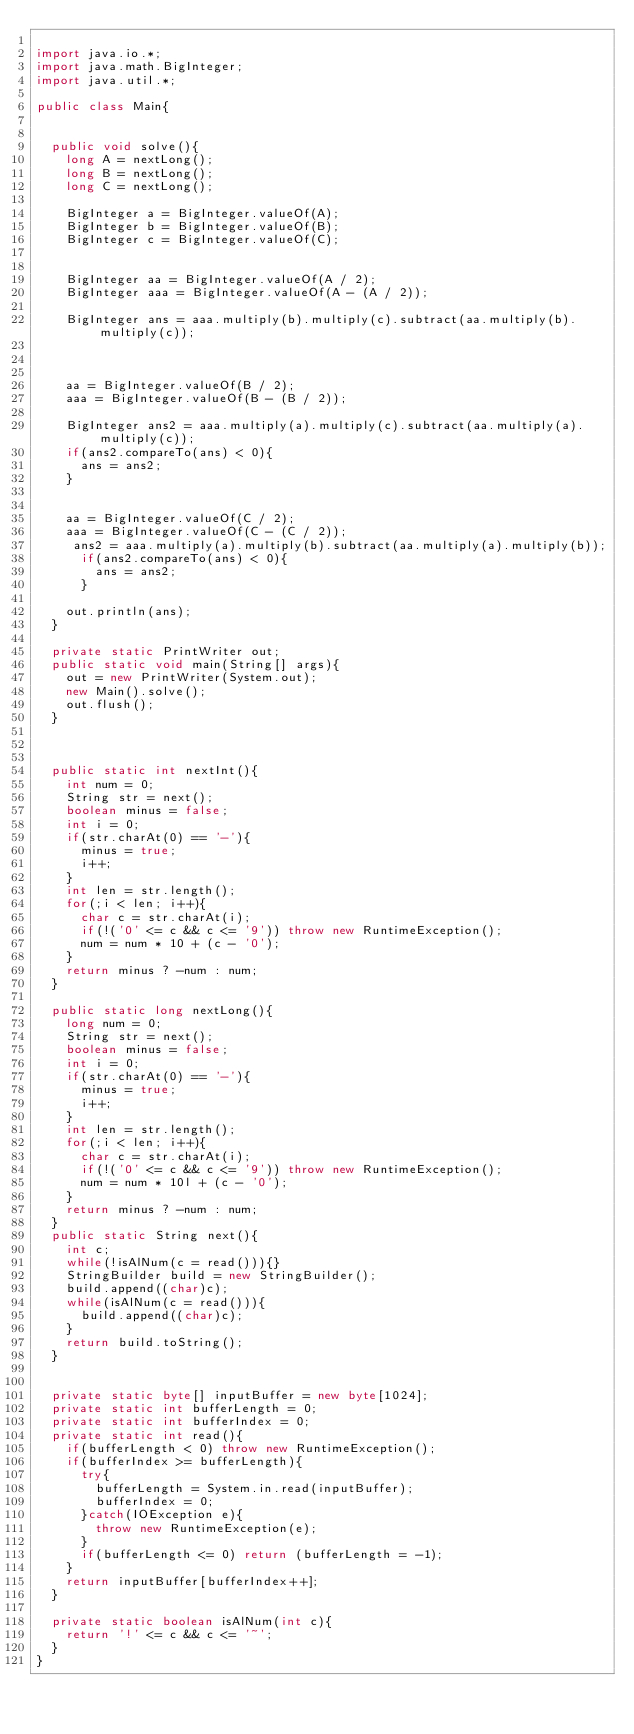Convert code to text. <code><loc_0><loc_0><loc_500><loc_500><_Java_>
import java.io.*;
import java.math.BigInteger;
import java.util.*;
 
public class Main{
	
 
	public void solve(){
		long A = nextLong();
		long B = nextLong();
		long C = nextLong();

		BigInteger a = BigInteger.valueOf(A);
		BigInteger b = BigInteger.valueOf(B);
		BigInteger c = BigInteger.valueOf(C);
		
		
		BigInteger aa = BigInteger.valueOf(A / 2);
		BigInteger aaa = BigInteger.valueOf(A - (A / 2));
		
		BigInteger ans = aaa.multiply(b).multiply(c).subtract(aa.multiply(b).multiply(c));

		

		aa = BigInteger.valueOf(B / 2);
		aaa = BigInteger.valueOf(B - (B / 2));

		BigInteger ans2 = aaa.multiply(a).multiply(c).subtract(aa.multiply(a).multiply(c));
		if(ans2.compareTo(ans) < 0){
			ans = ans2;
		}
		

		aa = BigInteger.valueOf(C / 2);
		aaa = BigInteger.valueOf(C - (C / 2));
		 ans2 = aaa.multiply(a).multiply(b).subtract(aa.multiply(a).multiply(b));
			if(ans2.compareTo(ans) < 0){
				ans = ans2;
			}
			
		out.println(ans);
	}
	
	private static PrintWriter out;
	public static void main(String[] args){
		out = new PrintWriter(System.out);
		new Main().solve();
		out.flush();
	}
	
	
	
	public static int nextInt(){
		int num = 0;
		String str = next();
		boolean minus = false;
		int i = 0;
		if(str.charAt(0) == '-'){
			minus = true;
			i++;
		}
		int len = str.length();
		for(;i < len; i++){
			char c = str.charAt(i);
			if(!('0' <= c && c <= '9')) throw new RuntimeException();
			num = num * 10 + (c - '0');
		}
		return minus ? -num : num;
	}
	
	public static long nextLong(){
		long num = 0;
		String str = next();
		boolean minus = false;
		int i = 0;
		if(str.charAt(0) == '-'){
			minus = true;
			i++;
		}
		int len = str.length();
		for(;i < len; i++){
			char c = str.charAt(i);
			if(!('0' <= c && c <= '9')) throw new RuntimeException();
			num = num * 10l + (c - '0');
		}
		return minus ? -num : num;
	}
	public static String next(){
		int c;
		while(!isAlNum(c = read())){}
		StringBuilder build = new StringBuilder();
		build.append((char)c);
		while(isAlNum(c = read())){
			build.append((char)c);
		}
		return build.toString();
	}
	
	
	private static byte[] inputBuffer = new byte[1024];
	private static int bufferLength = 0;
	private static int bufferIndex = 0;
	private static int read(){
		if(bufferLength < 0) throw new RuntimeException();
		if(bufferIndex >= bufferLength){
			try{
				bufferLength = System.in.read(inputBuffer);
				bufferIndex = 0;
			}catch(IOException e){
				throw new RuntimeException(e);
			}
			if(bufferLength <= 0) return (bufferLength = -1);
		}
		return inputBuffer[bufferIndex++];
	}
	
	private static boolean isAlNum(int c){
		return '!' <= c && c <= '~';
	}
}</code> 